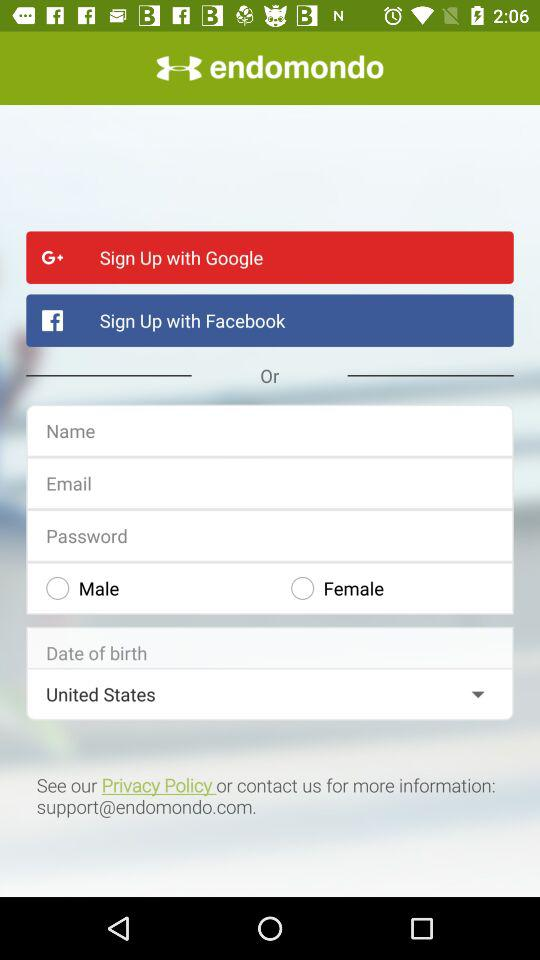What is the name of the application? The name of the application is "endomondo". 